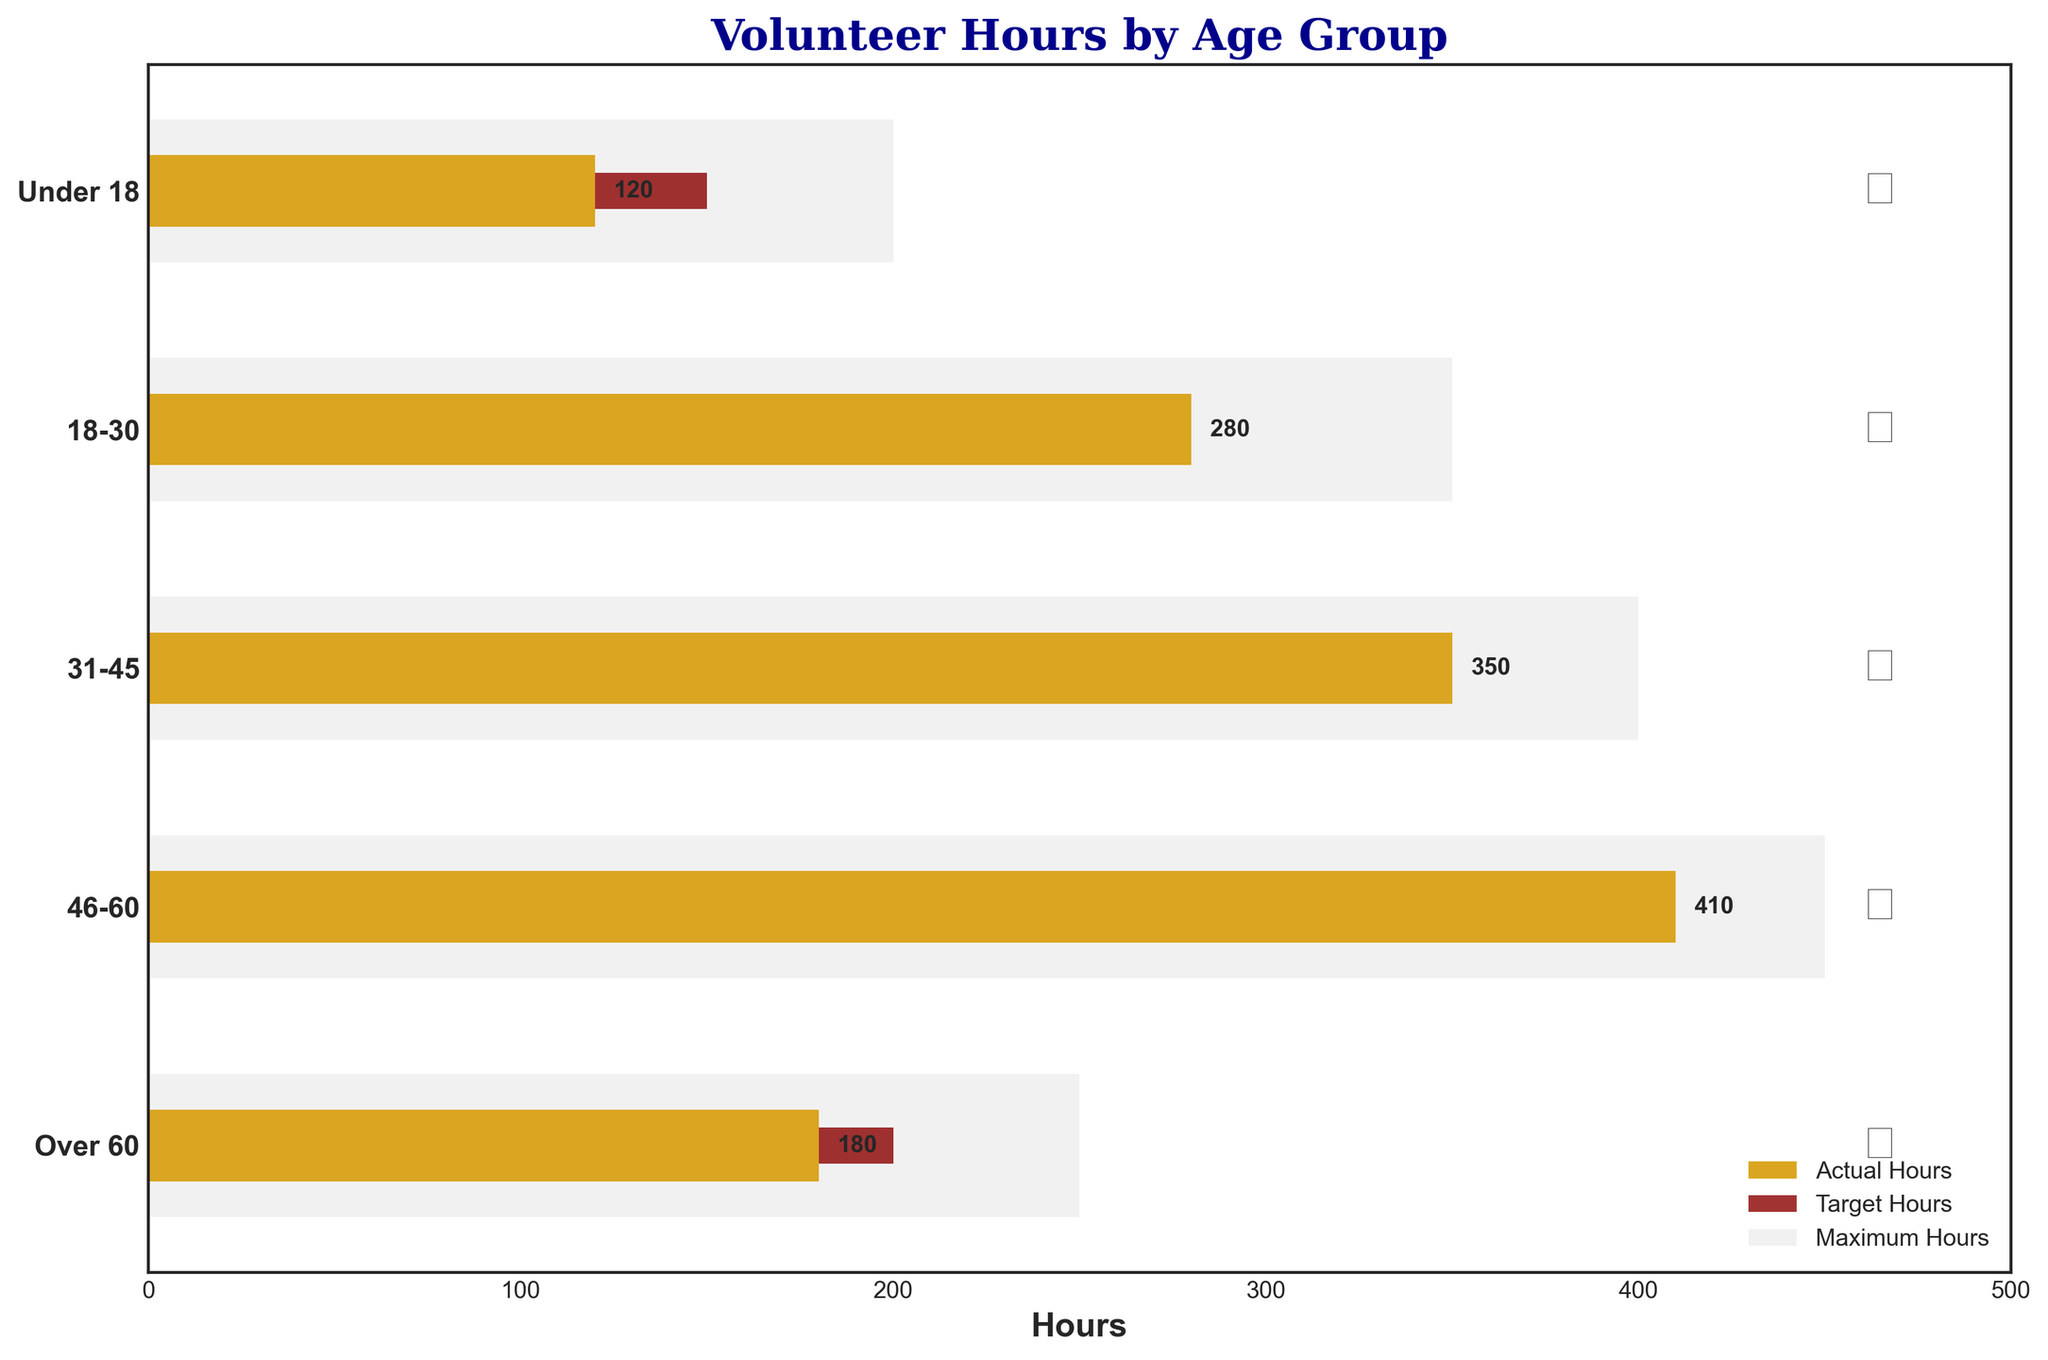What's the title of the figure? The title is located at the top of the figure in a larger, bold font. It reads "Volunteer Hours by Age Group."
Answer: Volunteer Hours by Age Group Which age group contributed the fewest volunteer hours? By looking at the lengths of the goldenrod bars, the shortest bar corresponds to the "Under 18" group. This bar represents 120 volunteer hours.
Answer: Under 18 Which bar represents the target hours in the figure? The target hours are represented by the dark red bars. Each age group has a shorter dark red bar indicating their target hours.
Answer: Dark red bars How many age groups exceeded their target hours? By comparing the goldenrod bars (actual volunteer hours) to the dark red bars (target hours) for each age group, the groups "18-30," "31-45," and "46-60" all have longer goldenrod bars than dark red bars, indicating these groups exceeded their target hours.
Answer: Three age groups What is the difference between actual and target volunteer hours for the "46-60" age group? The actual volunteer hours for the "46-60" age group are 410, and their target hours are 350. Subtracting the target hours from the actual hours gives 410 - 350 = 60.
Answer: 60 Which age group has the largest difference between maximum hours and target hours? By subtracting the target hours from the maximum hours for each age group and comparing the results, the "Under 18" group has the largest difference (200 - 150 = 50).
Answer: Under 18 What is the average of the actual volunteer hours across all age groups? Sum the actual volunteer hours for all age groups: 120 + 280 + 350 + 410 + 180 = 1340. Then divide by the number of age groups, which is 5. The average is 1340 / 5 = 268.
Answer: 268 Do all age groups have their maximum hours shown in light grey? Yes, each age group has a corresponding light grey bar behind the smaller goldenrod and dark red bars, indicating their maximum allowable hours.
Answer: Yes Which age group narrowly missed their target hours? By comparing the goldenrod and dark red bars, the "Over 60" age group shows the goldenrod bar (actual hours of 180) close to but not quite reaching the dark red bar (target hours of 200).
Answer: Over 60 What is the median of the target hours across all age groups? The target hours for the age groups are: 150, 250, 300, 350, 200. When these values are sorted (150, 200, 250, 300, 350), the median is the middle value, which is 250.
Answer: 250 